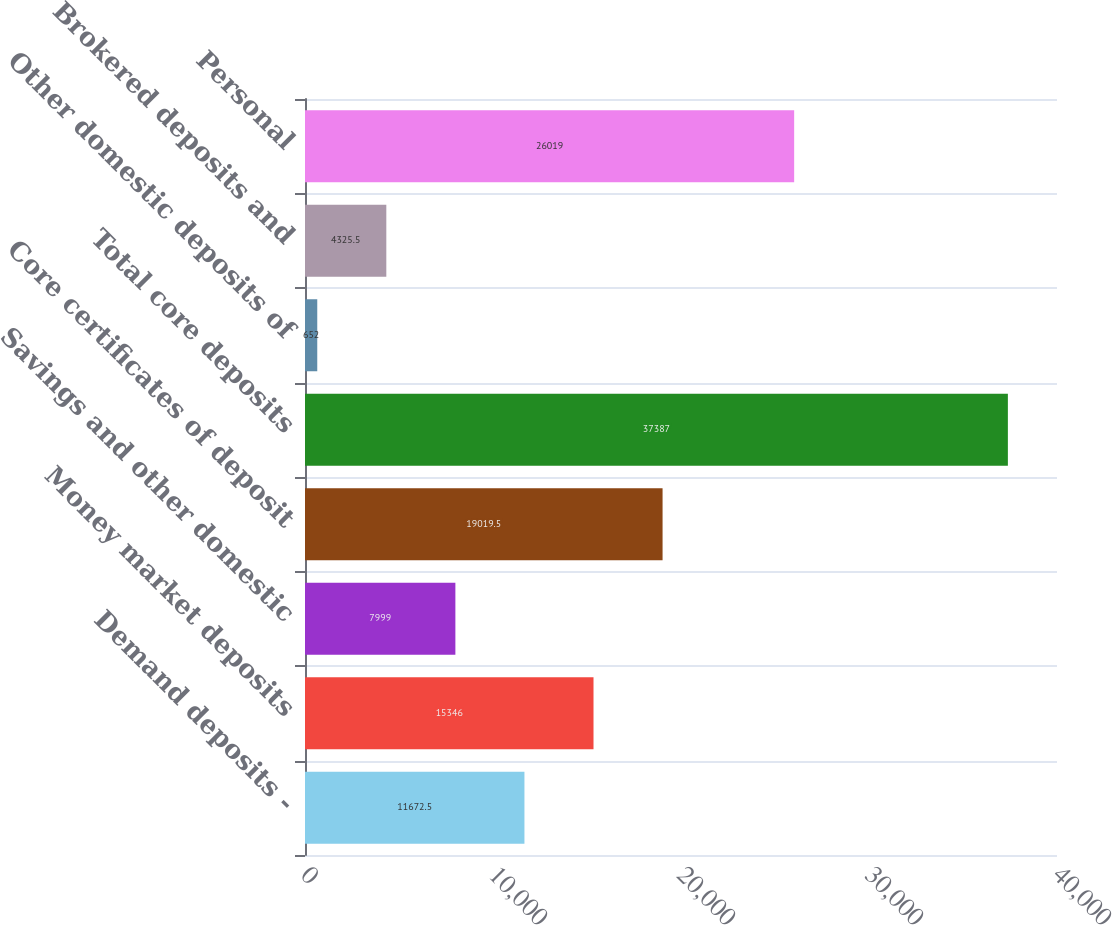<chart> <loc_0><loc_0><loc_500><loc_500><bar_chart><fcel>Demand deposits -<fcel>Money market deposits<fcel>Savings and other domestic<fcel>Core certificates of deposit<fcel>Total core deposits<fcel>Other domestic deposits of<fcel>Brokered deposits and<fcel>Personal<nl><fcel>11672.5<fcel>15346<fcel>7999<fcel>19019.5<fcel>37387<fcel>652<fcel>4325.5<fcel>26019<nl></chart> 